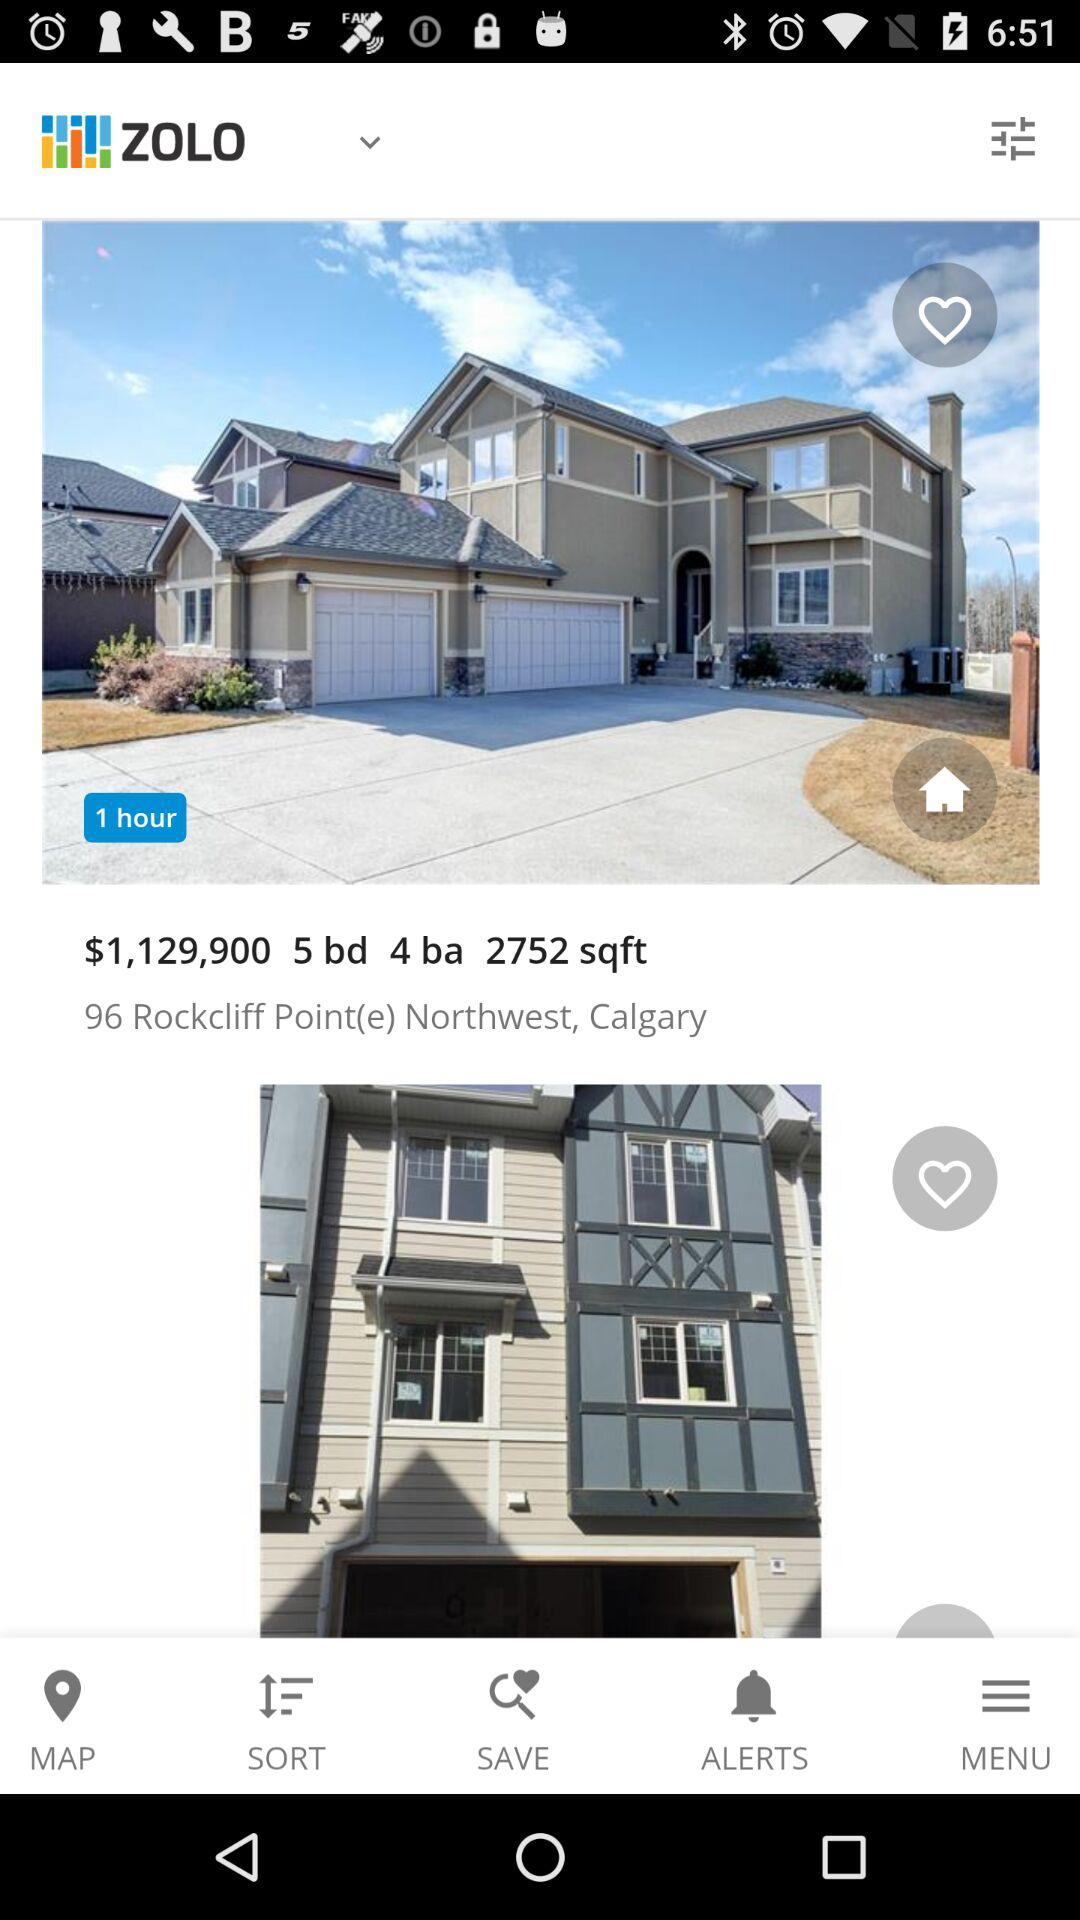How many bedrooms does this house have?
Answer the question using a single word or phrase. 5 